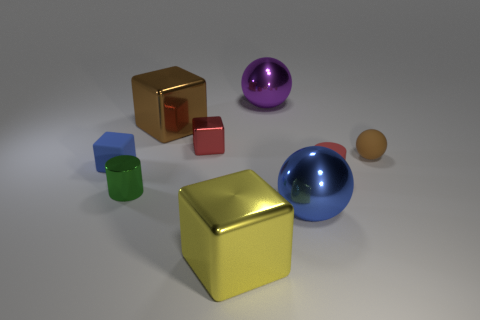There is a small thing that is in front of the tiny cylinder that is to the right of the big brown shiny thing; what color is it?
Offer a terse response. Green. Is the number of small objects that are behind the large purple metal object less than the number of red matte things that are right of the small red matte object?
Give a very brief answer. No. Does the blue matte cube have the same size as the cube that is in front of the blue cube?
Your answer should be very brief. No. The big metal thing that is both behind the big blue shiny ball and right of the tiny shiny cube has what shape?
Your answer should be compact. Sphere. There is a purple object that is made of the same material as the small red cube; what is its size?
Provide a succinct answer. Large. How many small red things are in front of the tiny cylinder that is left of the large blue thing?
Provide a short and direct response. 0. Does the block behind the small red metallic thing have the same material as the big blue thing?
Provide a succinct answer. Yes. Is there anything else that has the same material as the red block?
Provide a short and direct response. Yes. What is the size of the ball on the left side of the blue thing that is right of the purple metallic sphere?
Make the answer very short. Large. What is the size of the blue object that is left of the big block that is behind the small cylinder on the left side of the big blue shiny sphere?
Offer a very short reply. Small. 